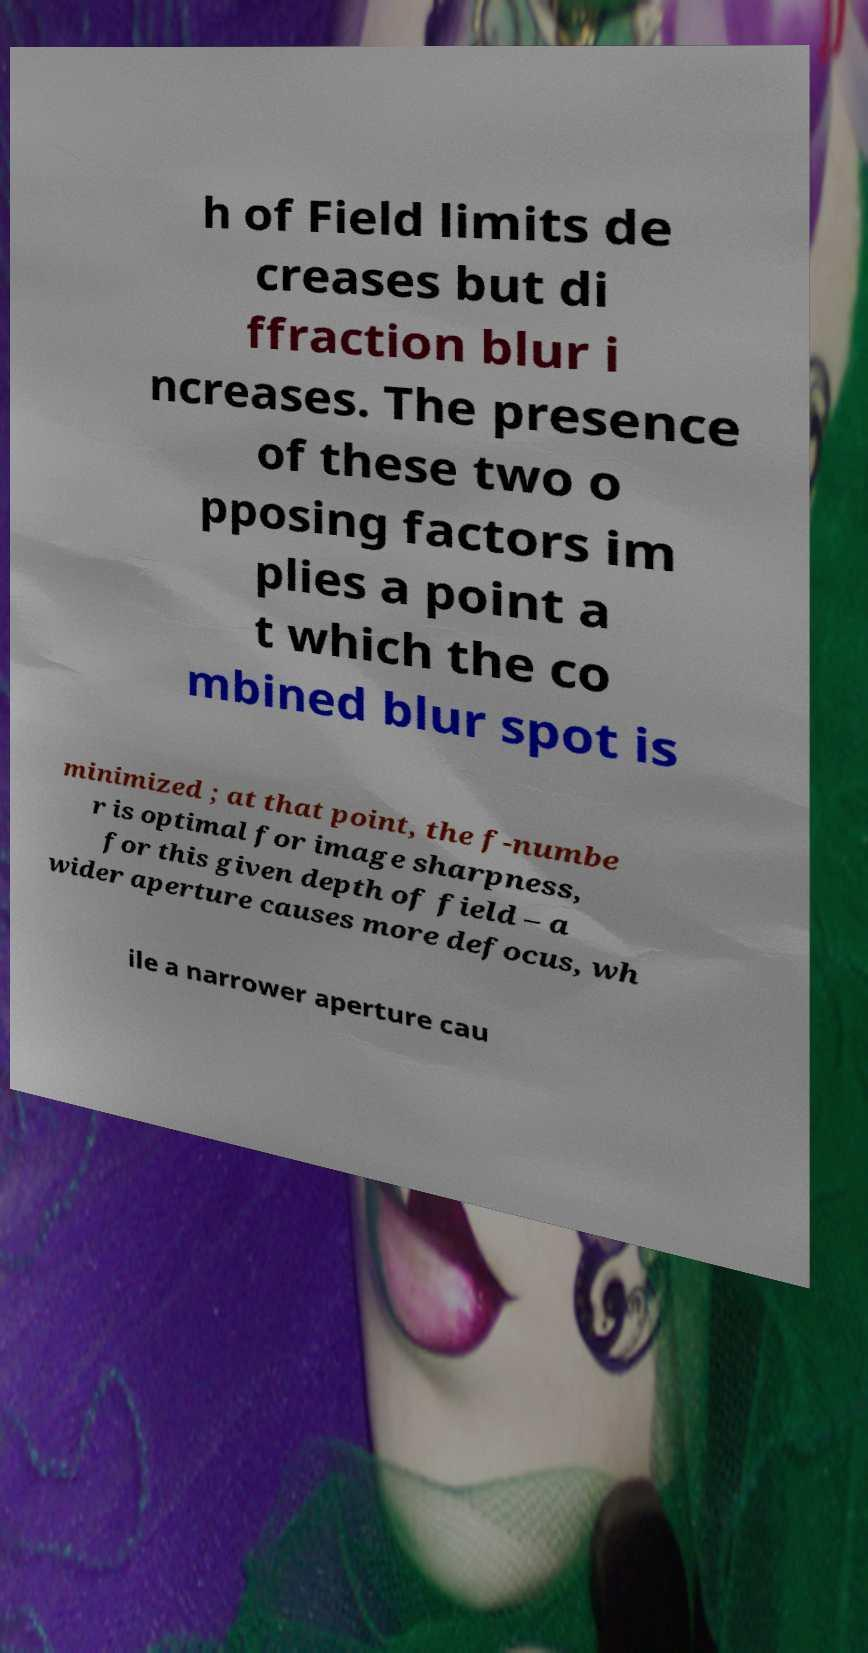Please identify and transcribe the text found in this image. h of Field limits de creases but di ffraction blur i ncreases. The presence of these two o pposing factors im plies a point a t which the co mbined blur spot is minimized ; at that point, the f-numbe r is optimal for image sharpness, for this given depth of field – a wider aperture causes more defocus, wh ile a narrower aperture cau 